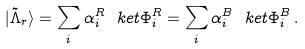<formula> <loc_0><loc_0><loc_500><loc_500>| \tilde { \Lambda } _ { r } \rangle = \sum _ { i } \alpha ^ { R } _ { i } \ k e t { \Phi ^ { R } _ { i } } = \sum _ { i } \alpha ^ { B } _ { i } \ k e t { \Phi ^ { B } _ { i } } \, .</formula> 